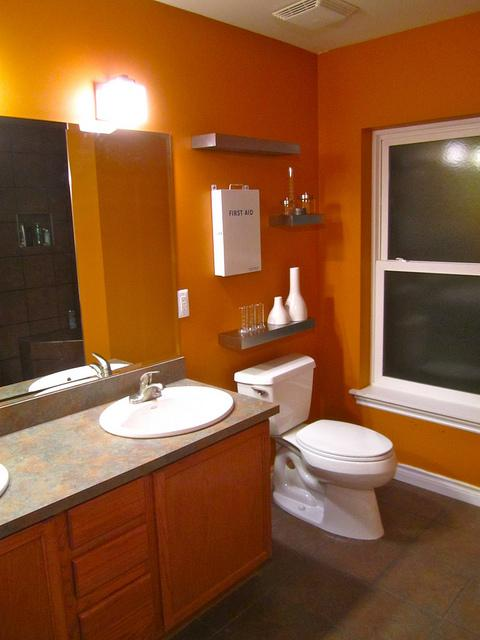What color is the writing on front of the first aid case on the wall? black 